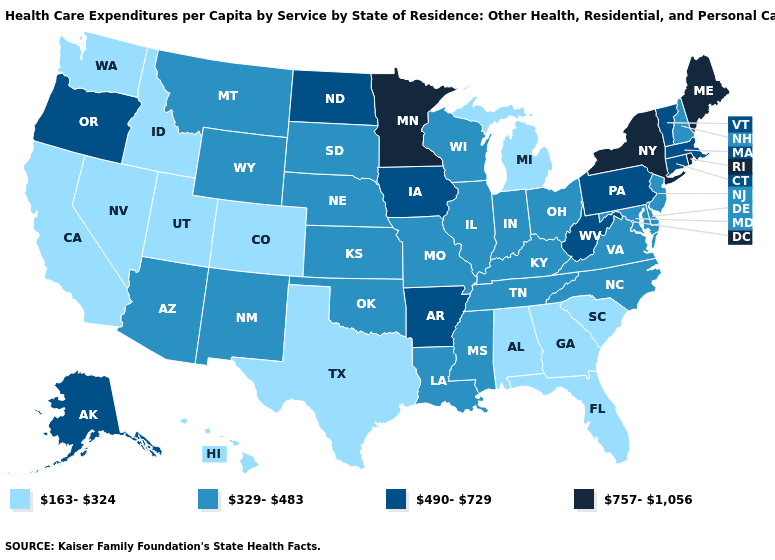Among the states that border New Hampshire , does Vermont have the highest value?
Be succinct. No. Does the map have missing data?
Answer briefly. No. Which states have the lowest value in the USA?
Write a very short answer. Alabama, California, Colorado, Florida, Georgia, Hawaii, Idaho, Michigan, Nevada, South Carolina, Texas, Utah, Washington. What is the lowest value in the USA?
Write a very short answer. 163-324. What is the highest value in the MidWest ?
Short answer required. 757-1,056. Does Delaware have a lower value than Alaska?
Concise answer only. Yes. How many symbols are there in the legend?
Answer briefly. 4. Name the states that have a value in the range 490-729?
Give a very brief answer. Alaska, Arkansas, Connecticut, Iowa, Massachusetts, North Dakota, Oregon, Pennsylvania, Vermont, West Virginia. What is the value of Georgia?
Concise answer only. 163-324. Does the first symbol in the legend represent the smallest category?
Write a very short answer. Yes. Is the legend a continuous bar?
Give a very brief answer. No. What is the lowest value in the Northeast?
Short answer required. 329-483. What is the highest value in the South ?
Keep it brief. 490-729. What is the value of Texas?
Answer briefly. 163-324. Is the legend a continuous bar?
Give a very brief answer. No. 